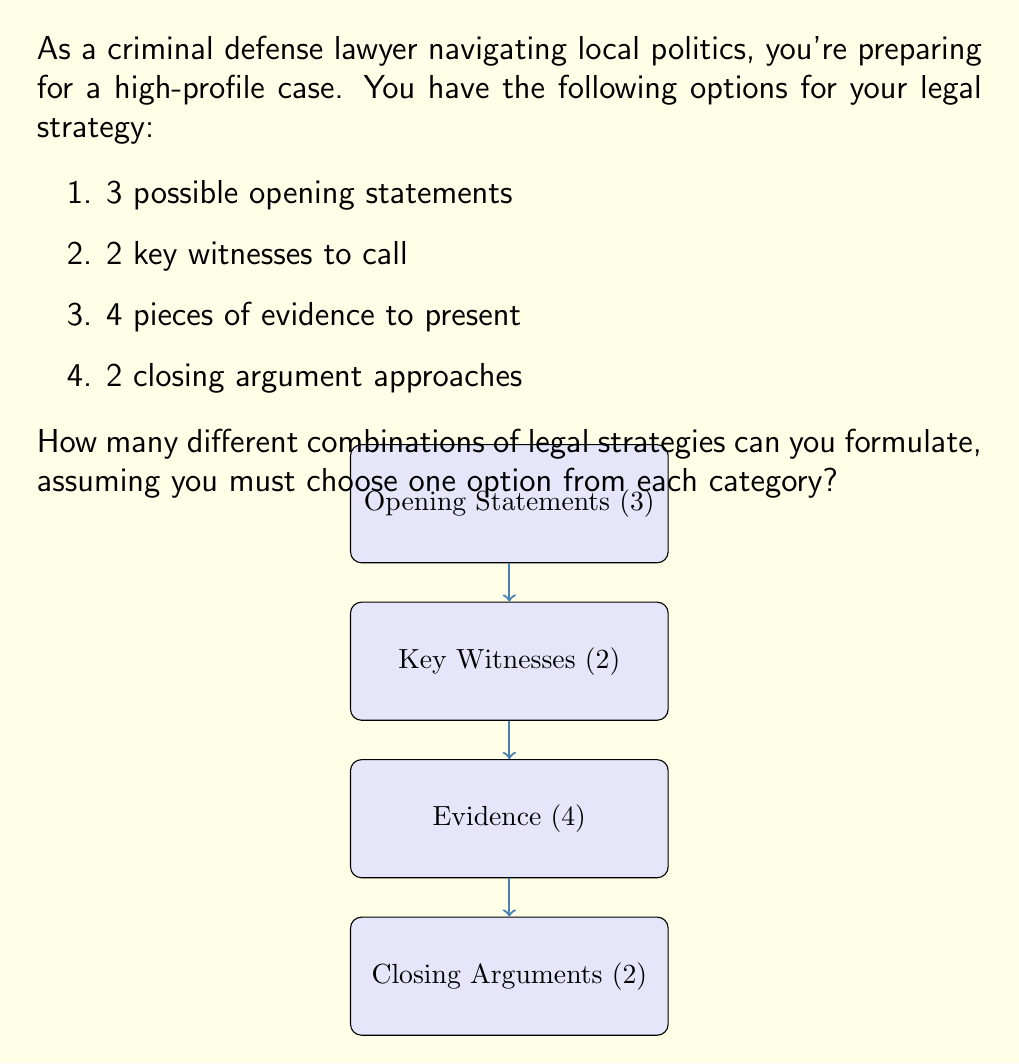Can you solve this math problem? To solve this problem, we can use the multiplication principle of counting. This principle states that if we have a sequence of independent choices, where there are:

- $n_1$ ways of making the first choice
- $n_2$ ways of making the second choice
- ...
- $n_k$ ways of making the $k$-th choice

Then the total number of ways to make all these choices is the product $n_1 \times n_2 \times ... \times n_k$.

In our case, we have:

1. 3 options for opening statements
2. 2 options for key witnesses
3. 4 options for evidence presentation
4. 2 options for closing arguments

Therefore, the total number of combinations is:

$$3 \times 2 \times 4 \times 2 = 48$$

We can break this down step-by-step:

1. Choose an opening statement (3 ways)
2. For each opening statement, choose a key witness (2 ways)
   $3 \times 2 = 6$ combinations so far
3. For each of these, choose evidence to present (4 ways)
   $6 \times 4 = 24$ combinations
4. Finally, for each of these, choose a closing argument approach (2 ways)
   $24 \times 2 = 48$ total combinations

This gives us the total number of possible legal strategy combinations.
Answer: 48 combinations 